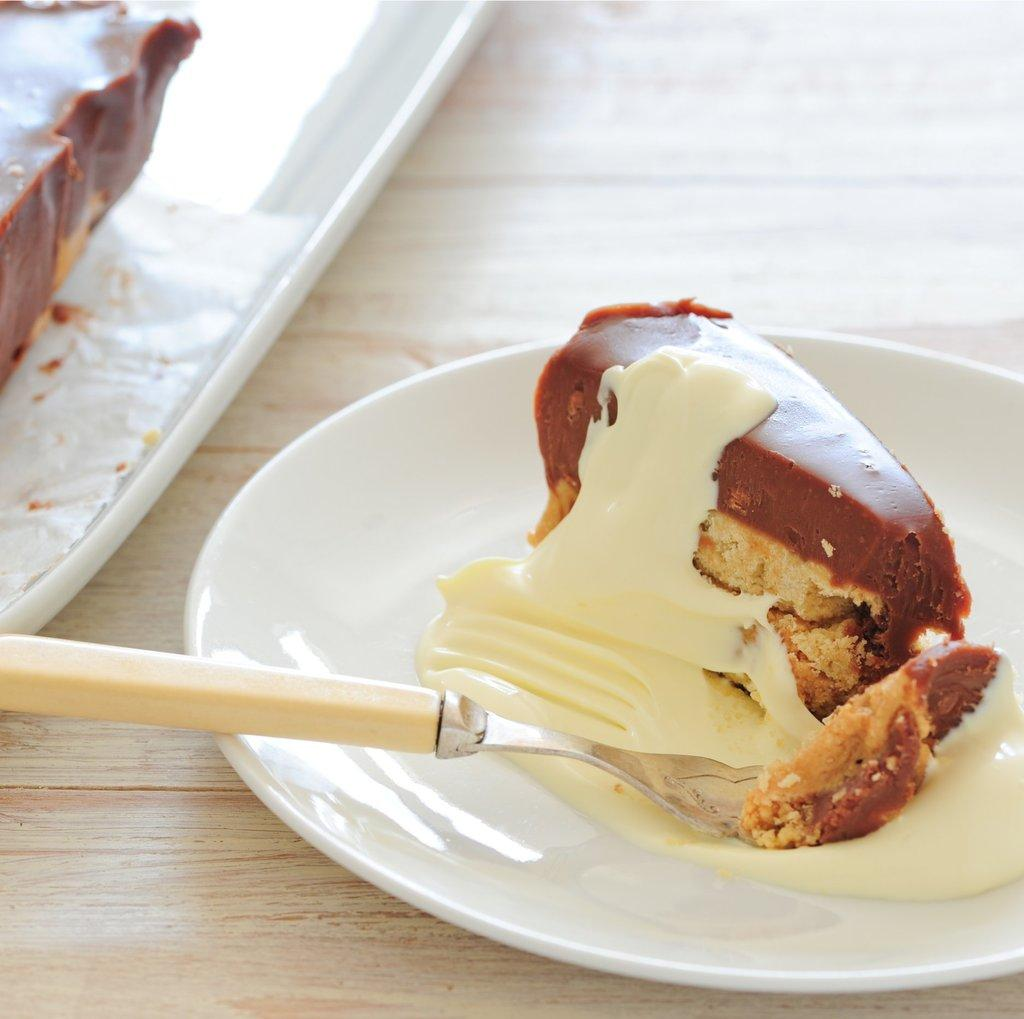What is the main object in the center of the image? There is a table in the center of the image. What is depicted on the table? There are planets depicted on the table. What utensil can be seen on the table? There is a fork on the table. What else is present on the table besides the planets and fork? There are food items on the table. What type of worm can be seen crawling on the planets in the image? There are no worms present in the image; it features planets and other objects on a table. 